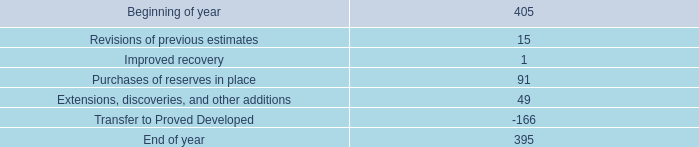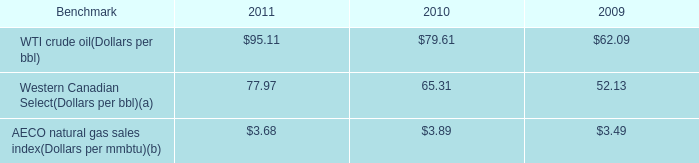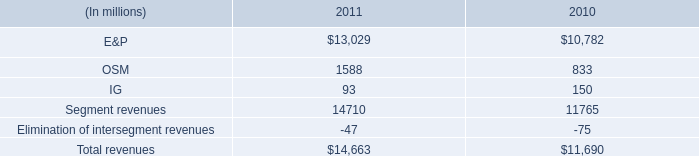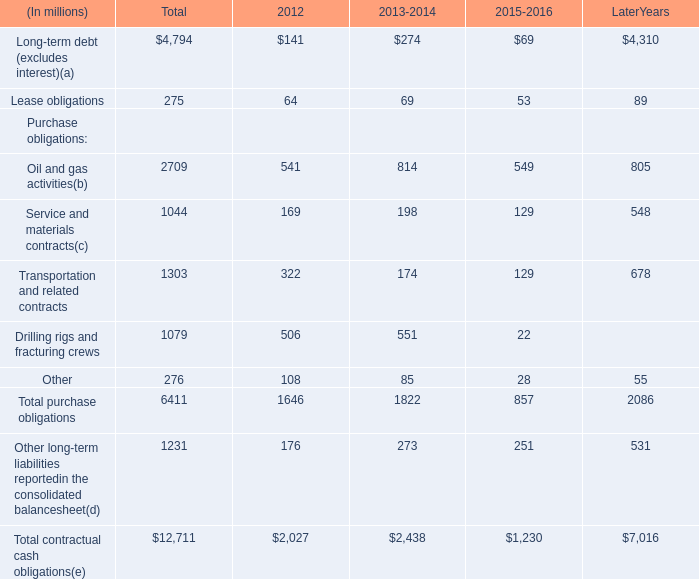how much has the western canadian select dollars per bbl increased since 2009? 
Computations: ((77.97 - 52.13) / 52.13)
Answer: 0.49568. 